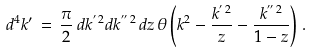Convert formula to latex. <formula><loc_0><loc_0><loc_500><loc_500>d ^ { 4 } k ^ { \prime } \, = \, \frac { \pi } { 2 } \, d k ^ { ^ { \prime } \, 2 } d k ^ { ^ { \prime \prime } \, 2 } \, d z \, \theta \left ( k ^ { 2 } - \frac { k ^ { ^ { \prime } \, 2 } } { z } - \frac { k ^ { ^ { \prime \prime } \, 2 } } { 1 - z } \right ) \, .</formula> 